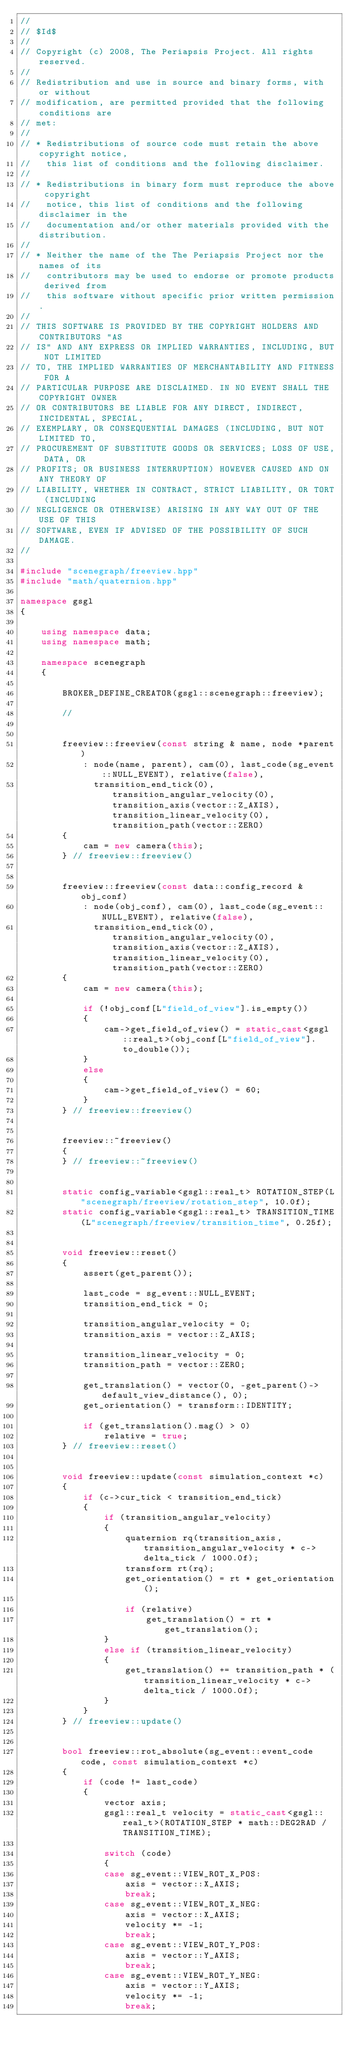<code> <loc_0><loc_0><loc_500><loc_500><_C++_>//
// $Id$
//
// Copyright (c) 2008, The Periapsis Project. All rights reserved. 
// 
// Redistribution and use in source and binary forms, with or without 
// modification, are permitted provided that the following conditions are 
// met: 
// 
// * Redistributions of source code must retain the above copyright notice, 
//   this list of conditions and the following disclaimer. 
// 
// * Redistributions in binary form must reproduce the above copyright 
//   notice, this list of conditions and the following disclaimer in the 
//   documentation and/or other materials provided with the distribution. 
// 
// * Neither the name of the The Periapsis Project nor the names of its 
//   contributors may be used to endorse or promote products derived from 
//   this software without specific prior written permission. 
// 
// THIS SOFTWARE IS PROVIDED BY THE COPYRIGHT HOLDERS AND CONTRIBUTORS "AS 
// IS" AND ANY EXPRESS OR IMPLIED WARRANTIES, INCLUDING, BUT NOT LIMITED 
// TO, THE IMPLIED WARRANTIES OF MERCHANTABILITY AND FITNESS FOR A 
// PARTICULAR PURPOSE ARE DISCLAIMED. IN NO EVENT SHALL THE COPYRIGHT OWNER 
// OR CONTRIBUTORS BE LIABLE FOR ANY DIRECT, INDIRECT, INCIDENTAL, SPECIAL, 
// EXEMPLARY, OR CONSEQUENTIAL DAMAGES (INCLUDING, BUT NOT LIMITED TO, 
// PROCUREMENT OF SUBSTITUTE GOODS OR SERVICES; LOSS OF USE, DATA, OR 
// PROFITS; OR BUSINESS INTERRUPTION) HOWEVER CAUSED AND ON ANY THEORY OF 
// LIABILITY, WHETHER IN CONTRACT, STRICT LIABILITY, OR TORT (INCLUDING 
// NEGLIGENCE OR OTHERWISE) ARISING IN ANY WAY OUT OF THE USE OF THIS 
// SOFTWARE, EVEN IF ADVISED OF THE POSSIBILITY OF SUCH DAMAGE.
//

#include "scenegraph/freeview.hpp"
#include "math/quaternion.hpp"

namespace gsgl
{

    using namespace data;
    using namespace math;
    
    namespace scenegraph
    {

        BROKER_DEFINE_CREATOR(gsgl::scenegraph::freeview);

        //

    
        freeview::freeview(const string & name, node *parent) 
            : node(name, parent), cam(0), last_code(sg_event::NULL_EVENT), relative(false),
              transition_end_tick(0), transition_angular_velocity(0), transition_axis(vector::Z_AXIS), transition_linear_velocity(0), transition_path(vector::ZERO)
        {
            cam = new camera(this);
        } // freeview::freeview()
        

        freeview::freeview(const data::config_record & obj_conf) 
            : node(obj_conf), cam(0), last_code(sg_event::NULL_EVENT), relative(false),
              transition_end_tick(0), transition_angular_velocity(0), transition_axis(vector::Z_AXIS), transition_linear_velocity(0), transition_path(vector::ZERO)
        {
            cam = new camera(this);

            if (!obj_conf[L"field_of_view"].is_empty())
            {
                cam->get_field_of_view() = static_cast<gsgl::real_t>(obj_conf[L"field_of_view"].to_double());
            }
            else
            {
                cam->get_field_of_view() = 60;
            }
        } // freeview::freeview()

        
        freeview::~freeview()
        {
        } // freeview::~freeview()
        
        
        static config_variable<gsgl::real_t> ROTATION_STEP(L"scenegraph/freeview/rotation_step", 10.0f);
        static config_variable<gsgl::real_t> TRANSITION_TIME(L"scenegraph/freeview/transition_time", 0.25f);


        void freeview::reset()
        {
            assert(get_parent());

            last_code = sg_event::NULL_EVENT;
            transition_end_tick = 0;
            
            transition_angular_velocity = 0;
            transition_axis = vector::Z_AXIS;

            transition_linear_velocity = 0;
            transition_path = vector::ZERO;

            get_translation() = vector(0, -get_parent()->default_view_distance(), 0);
            get_orientation() = transform::IDENTITY;

            if (get_translation().mag() > 0)
                relative = true;
        } // freeview::reset()


        void freeview::update(const simulation_context *c)
        {
            if (c->cur_tick < transition_end_tick)
            {
                if (transition_angular_velocity)
                {
                    quaternion rq(transition_axis, transition_angular_velocity * c->delta_tick / 1000.0f);
                    transform rt(rq);
                    get_orientation() = rt * get_orientation();

                    if (relative)
                        get_translation() = rt * get_translation();
                }
                else if (transition_linear_velocity)
                {
                    get_translation() += transition_path * (transition_linear_velocity * c->delta_tick / 1000.0f);
                }
            }
        } // freeview::update()


        bool freeview::rot_absolute(sg_event::event_code code, const simulation_context *c)
        {
            if (code != last_code)
            {
                vector axis;
                gsgl::real_t velocity = static_cast<gsgl::real_t>(ROTATION_STEP * math::DEG2RAD / TRANSITION_TIME);
                
                switch (code)
                {
                case sg_event::VIEW_ROT_X_POS:
                    axis = vector::X_AXIS;
                    break;
                case sg_event::VIEW_ROT_X_NEG:
                    axis = vector::X_AXIS;
                    velocity *= -1;
                    break;
                case sg_event::VIEW_ROT_Y_POS:
                    axis = vector::Y_AXIS;
                    break;
                case sg_event::VIEW_ROT_Y_NEG:
                    axis = vector::Y_AXIS;
                    velocity *= -1;
                    break;</code> 